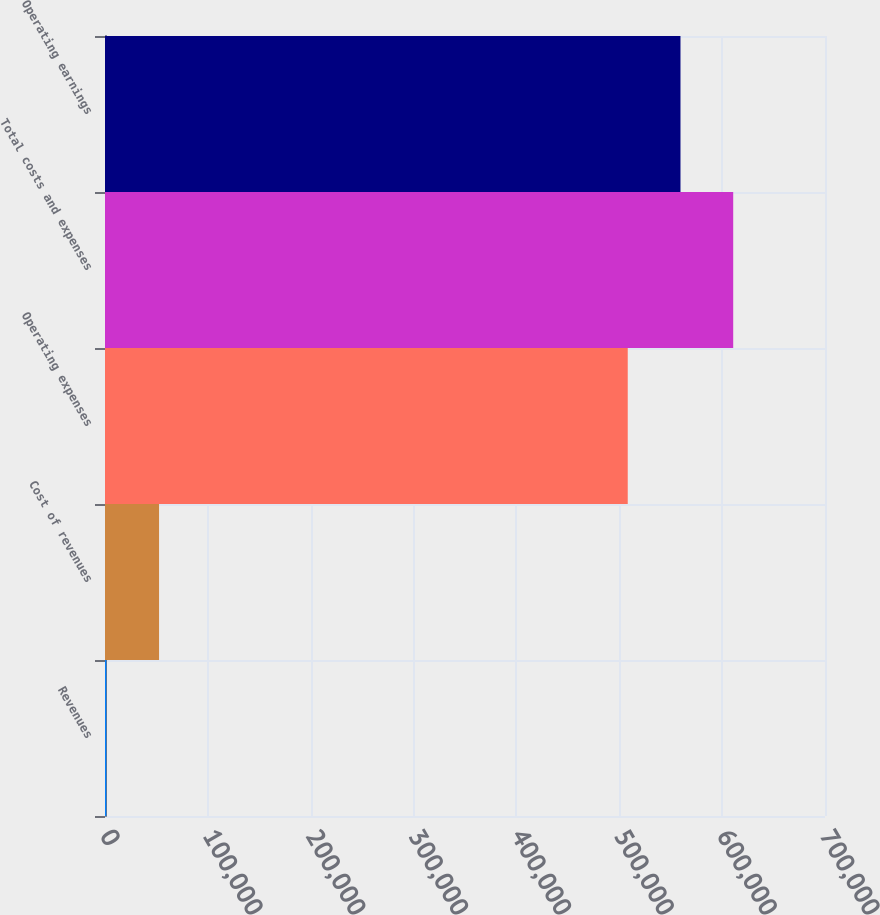<chart> <loc_0><loc_0><loc_500><loc_500><bar_chart><fcel>Revenues<fcel>Cost of revenues<fcel>Operating expenses<fcel>Total costs and expenses<fcel>Operating earnings<nl><fcel>1290<fcel>52556.2<fcel>508224<fcel>610756<fcel>559490<nl></chart> 